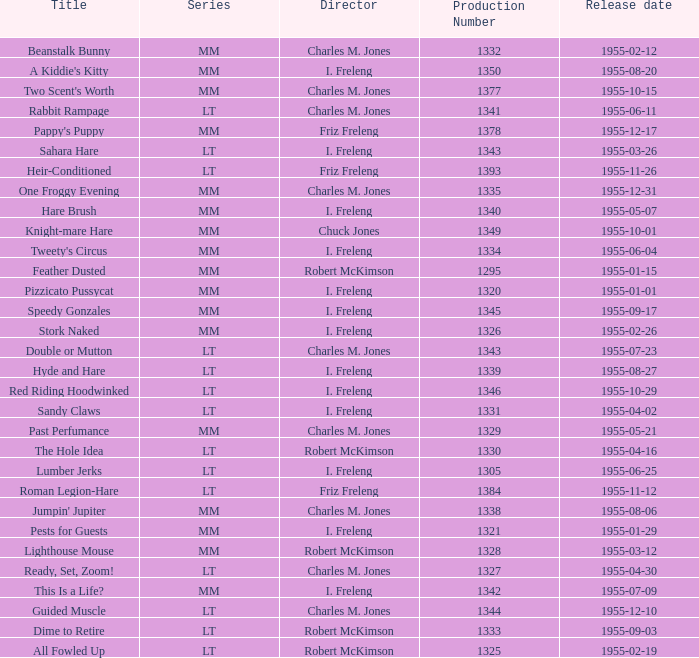What is the highest production number released on 1955-04-02 with i. freleng as the director? 1331.0. 